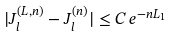Convert formula to latex. <formula><loc_0><loc_0><loc_500><loc_500>| J _ { l } ^ { ( L , n ) } - J _ { l } ^ { ( n ) } | \leq C \, e ^ { - n L _ { 1 } }</formula> 